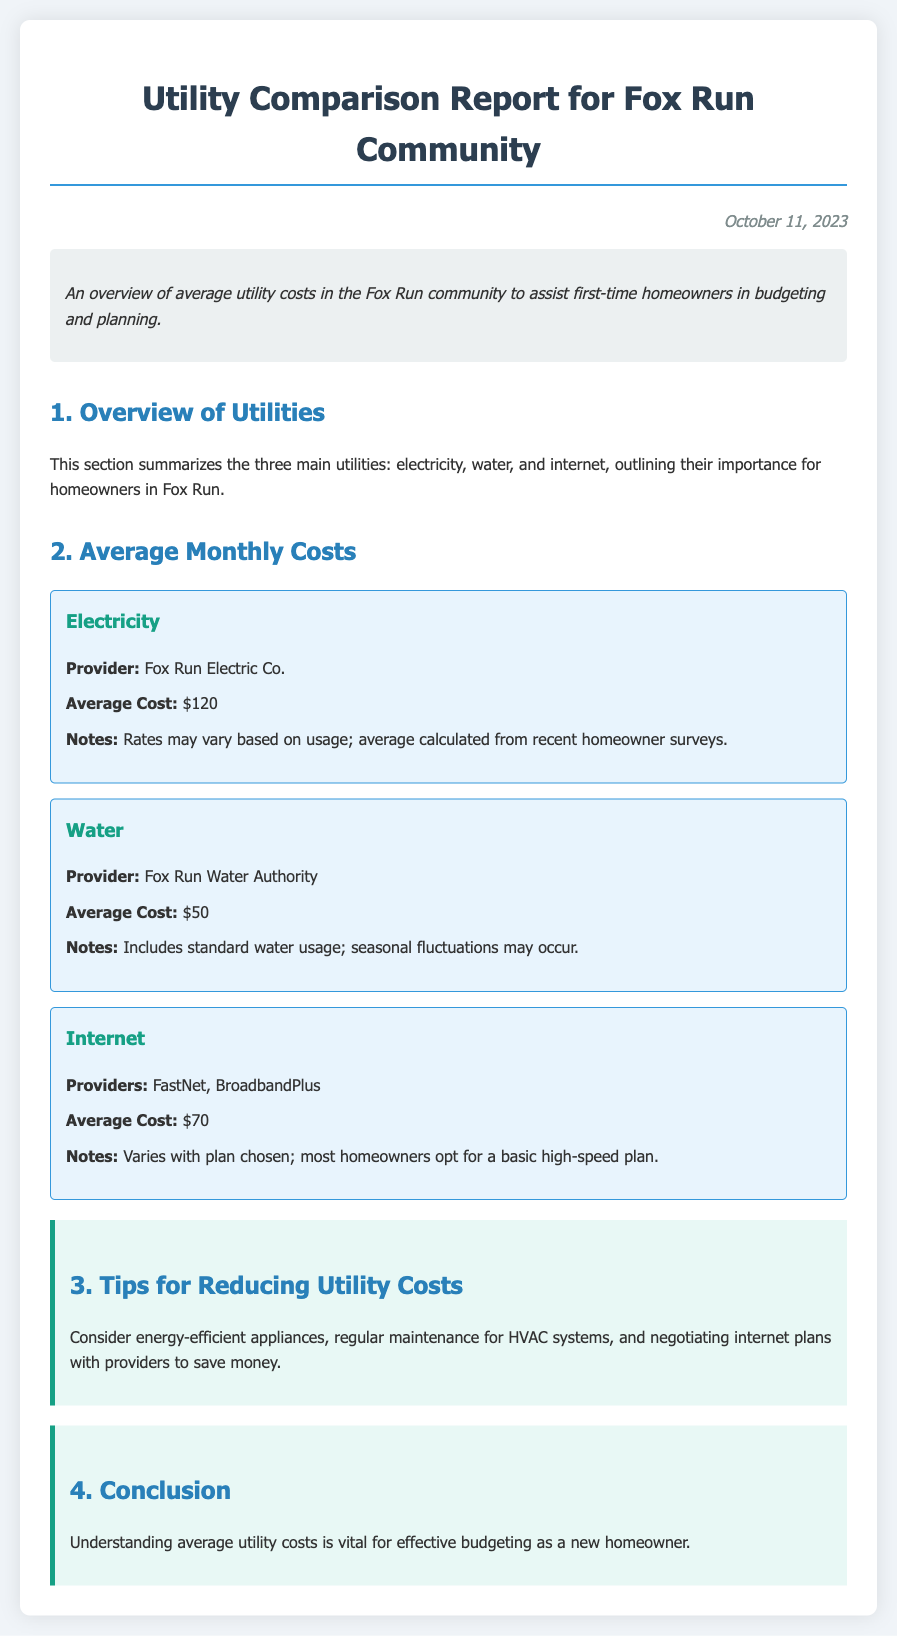What is the average cost for electricity? The average cost for electricity in the Fox Run community is mentioned in the document under the Electricity section.
Answer: $120 Who provides the water service? The water service provider is listed in the Water section of the document.
Answer: Fox Run Water Authority What is the average cost for internet? The internet average cost is specified in the Internet section of the document.
Answer: $70 What tips are provided for reducing utility costs? The document includes a tips section that provides recommendations for saving on utilities.
Answer: Consider energy-efficient appliances What is the date of the report? The report date is found in the header of the document.
Answer: October 11, 2023 How many internet providers are mentioned? The Internet section lists the companies providing internet services.
Answer: Two What is the average cost for water? The average cost for water is outlined in the Water section of the document.
Answer: $50 What is the significance of understanding average utility costs? The conclusion discusses the importance of average utility costs for budgeting.
Answer: Effective budgeting What must homeowners do to reduce internet costs? The tips section suggests actions regarding internet plans.
Answer: Negotiating internet plans 